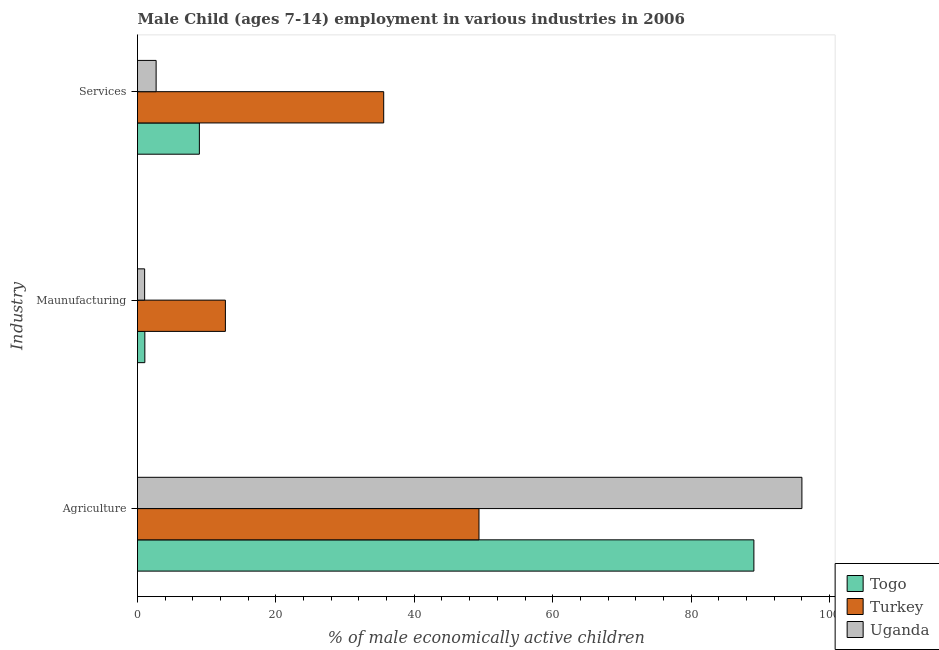How many different coloured bars are there?
Your answer should be very brief. 3. Are the number of bars on each tick of the Y-axis equal?
Offer a terse response. Yes. How many bars are there on the 1st tick from the top?
Keep it short and to the point. 3. How many bars are there on the 1st tick from the bottom?
Give a very brief answer. 3. What is the label of the 1st group of bars from the top?
Provide a short and direct response. Services. What is the percentage of economically active children in manufacturing in Togo?
Provide a short and direct response. 1.06. Across all countries, what is the maximum percentage of economically active children in services?
Make the answer very short. 35.58. Across all countries, what is the minimum percentage of economically active children in services?
Provide a succinct answer. 2.69. In which country was the percentage of economically active children in manufacturing minimum?
Make the answer very short. Uganda. What is the total percentage of economically active children in services in the graph?
Provide a short and direct response. 47.21. What is the difference between the percentage of economically active children in agriculture in Uganda and that in Togo?
Provide a short and direct response. 6.94. What is the difference between the percentage of economically active children in services in Turkey and the percentage of economically active children in manufacturing in Togo?
Offer a very short reply. 34.52. What is the average percentage of economically active children in services per country?
Your response must be concise. 15.74. What is the difference between the percentage of economically active children in agriculture and percentage of economically active children in manufacturing in Uganda?
Your answer should be compact. 94.99. What is the ratio of the percentage of economically active children in services in Togo to that in Uganda?
Your answer should be very brief. 3.32. What is the difference between the highest and the second highest percentage of economically active children in services?
Provide a succinct answer. 26.64. What is the difference between the highest and the lowest percentage of economically active children in agriculture?
Provide a short and direct response. 46.67. In how many countries, is the percentage of economically active children in agriculture greater than the average percentage of economically active children in agriculture taken over all countries?
Offer a terse response. 2. What does the 3rd bar from the top in Services represents?
Give a very brief answer. Togo. What does the 1st bar from the bottom in Maunufacturing represents?
Give a very brief answer. Togo. Are all the bars in the graph horizontal?
Provide a short and direct response. Yes. What is the difference between two consecutive major ticks on the X-axis?
Your response must be concise. 20. Are the values on the major ticks of X-axis written in scientific E-notation?
Your answer should be compact. No. Does the graph contain any zero values?
Your response must be concise. No. What is the title of the graph?
Provide a short and direct response. Male Child (ages 7-14) employment in various industries in 2006. Does "Kazakhstan" appear as one of the legend labels in the graph?
Ensure brevity in your answer.  No. What is the label or title of the X-axis?
Give a very brief answer. % of male economically active children. What is the label or title of the Y-axis?
Provide a short and direct response. Industry. What is the % of male economically active children of Togo in Agriculture?
Keep it short and to the point. 89.08. What is the % of male economically active children of Turkey in Agriculture?
Ensure brevity in your answer.  49.35. What is the % of male economically active children of Uganda in Agriculture?
Make the answer very short. 96.02. What is the % of male economically active children in Togo in Maunufacturing?
Provide a short and direct response. 1.06. What is the % of male economically active children of Uganda in Maunufacturing?
Offer a very short reply. 1.03. What is the % of male economically active children in Togo in Services?
Make the answer very short. 8.94. What is the % of male economically active children in Turkey in Services?
Your answer should be very brief. 35.58. What is the % of male economically active children in Uganda in Services?
Provide a succinct answer. 2.69. Across all Industry, what is the maximum % of male economically active children of Togo?
Offer a terse response. 89.08. Across all Industry, what is the maximum % of male economically active children of Turkey?
Make the answer very short. 49.35. Across all Industry, what is the maximum % of male economically active children in Uganda?
Offer a terse response. 96.02. Across all Industry, what is the minimum % of male economically active children of Togo?
Ensure brevity in your answer.  1.06. Across all Industry, what is the minimum % of male economically active children of Turkey?
Provide a succinct answer. 12.7. Across all Industry, what is the minimum % of male economically active children in Uganda?
Give a very brief answer. 1.03. What is the total % of male economically active children in Togo in the graph?
Provide a short and direct response. 99.08. What is the total % of male economically active children in Turkey in the graph?
Make the answer very short. 97.63. What is the total % of male economically active children of Uganda in the graph?
Offer a terse response. 99.74. What is the difference between the % of male economically active children in Togo in Agriculture and that in Maunufacturing?
Ensure brevity in your answer.  88.02. What is the difference between the % of male economically active children of Turkey in Agriculture and that in Maunufacturing?
Your response must be concise. 36.65. What is the difference between the % of male economically active children of Uganda in Agriculture and that in Maunufacturing?
Make the answer very short. 94.99. What is the difference between the % of male economically active children of Togo in Agriculture and that in Services?
Your answer should be compact. 80.14. What is the difference between the % of male economically active children of Turkey in Agriculture and that in Services?
Your response must be concise. 13.77. What is the difference between the % of male economically active children in Uganda in Agriculture and that in Services?
Keep it short and to the point. 93.33. What is the difference between the % of male economically active children in Togo in Maunufacturing and that in Services?
Keep it short and to the point. -7.88. What is the difference between the % of male economically active children in Turkey in Maunufacturing and that in Services?
Offer a very short reply. -22.88. What is the difference between the % of male economically active children of Uganda in Maunufacturing and that in Services?
Ensure brevity in your answer.  -1.66. What is the difference between the % of male economically active children of Togo in Agriculture and the % of male economically active children of Turkey in Maunufacturing?
Your answer should be compact. 76.38. What is the difference between the % of male economically active children in Togo in Agriculture and the % of male economically active children in Uganda in Maunufacturing?
Offer a very short reply. 88.05. What is the difference between the % of male economically active children in Turkey in Agriculture and the % of male economically active children in Uganda in Maunufacturing?
Offer a very short reply. 48.32. What is the difference between the % of male economically active children of Togo in Agriculture and the % of male economically active children of Turkey in Services?
Keep it short and to the point. 53.5. What is the difference between the % of male economically active children in Togo in Agriculture and the % of male economically active children in Uganda in Services?
Provide a succinct answer. 86.39. What is the difference between the % of male economically active children in Turkey in Agriculture and the % of male economically active children in Uganda in Services?
Give a very brief answer. 46.66. What is the difference between the % of male economically active children of Togo in Maunufacturing and the % of male economically active children of Turkey in Services?
Your response must be concise. -34.52. What is the difference between the % of male economically active children of Togo in Maunufacturing and the % of male economically active children of Uganda in Services?
Your answer should be very brief. -1.63. What is the difference between the % of male economically active children of Turkey in Maunufacturing and the % of male economically active children of Uganda in Services?
Ensure brevity in your answer.  10.01. What is the average % of male economically active children of Togo per Industry?
Keep it short and to the point. 33.03. What is the average % of male economically active children of Turkey per Industry?
Your answer should be very brief. 32.54. What is the average % of male economically active children of Uganda per Industry?
Your response must be concise. 33.25. What is the difference between the % of male economically active children in Togo and % of male economically active children in Turkey in Agriculture?
Keep it short and to the point. 39.73. What is the difference between the % of male economically active children in Togo and % of male economically active children in Uganda in Agriculture?
Your answer should be very brief. -6.94. What is the difference between the % of male economically active children of Turkey and % of male economically active children of Uganda in Agriculture?
Your response must be concise. -46.67. What is the difference between the % of male economically active children of Togo and % of male economically active children of Turkey in Maunufacturing?
Provide a succinct answer. -11.64. What is the difference between the % of male economically active children of Turkey and % of male economically active children of Uganda in Maunufacturing?
Give a very brief answer. 11.67. What is the difference between the % of male economically active children in Togo and % of male economically active children in Turkey in Services?
Make the answer very short. -26.64. What is the difference between the % of male economically active children in Togo and % of male economically active children in Uganda in Services?
Ensure brevity in your answer.  6.25. What is the difference between the % of male economically active children in Turkey and % of male economically active children in Uganda in Services?
Keep it short and to the point. 32.89. What is the ratio of the % of male economically active children in Togo in Agriculture to that in Maunufacturing?
Offer a terse response. 84.04. What is the ratio of the % of male economically active children in Turkey in Agriculture to that in Maunufacturing?
Your answer should be compact. 3.89. What is the ratio of the % of male economically active children of Uganda in Agriculture to that in Maunufacturing?
Your response must be concise. 93.22. What is the ratio of the % of male economically active children of Togo in Agriculture to that in Services?
Keep it short and to the point. 9.96. What is the ratio of the % of male economically active children of Turkey in Agriculture to that in Services?
Offer a terse response. 1.39. What is the ratio of the % of male economically active children in Uganda in Agriculture to that in Services?
Ensure brevity in your answer.  35.7. What is the ratio of the % of male economically active children of Togo in Maunufacturing to that in Services?
Your answer should be compact. 0.12. What is the ratio of the % of male economically active children in Turkey in Maunufacturing to that in Services?
Your response must be concise. 0.36. What is the ratio of the % of male economically active children in Uganda in Maunufacturing to that in Services?
Your response must be concise. 0.38. What is the difference between the highest and the second highest % of male economically active children in Togo?
Ensure brevity in your answer.  80.14. What is the difference between the highest and the second highest % of male economically active children in Turkey?
Give a very brief answer. 13.77. What is the difference between the highest and the second highest % of male economically active children in Uganda?
Your answer should be compact. 93.33. What is the difference between the highest and the lowest % of male economically active children of Togo?
Offer a terse response. 88.02. What is the difference between the highest and the lowest % of male economically active children in Turkey?
Your answer should be compact. 36.65. What is the difference between the highest and the lowest % of male economically active children in Uganda?
Make the answer very short. 94.99. 